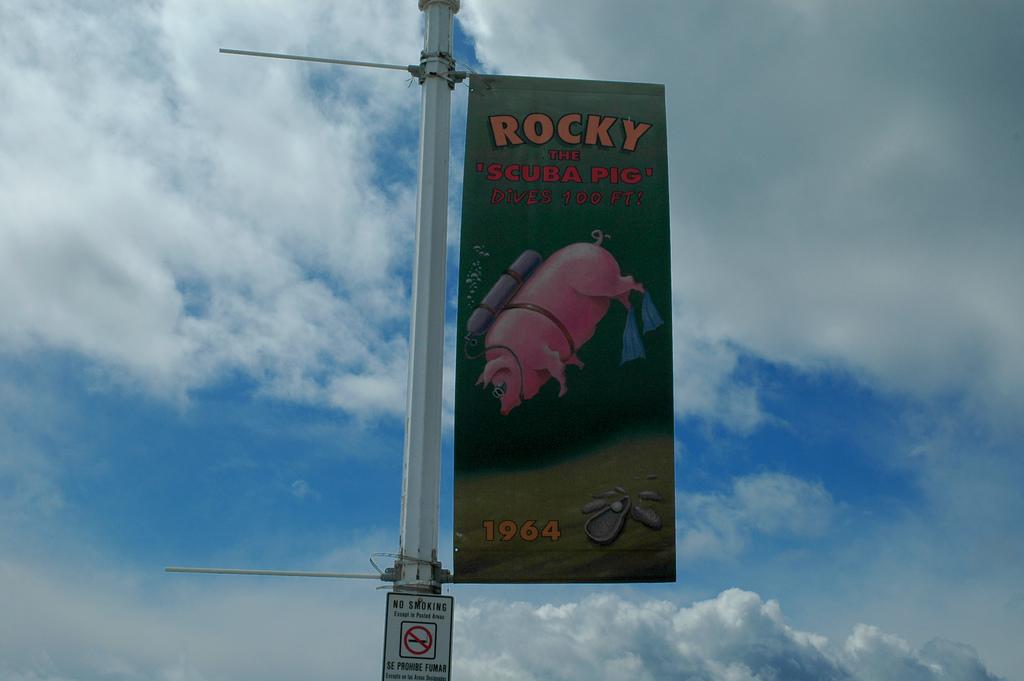What kind of pig does it say it is?
Provide a short and direct response. Scuba. 